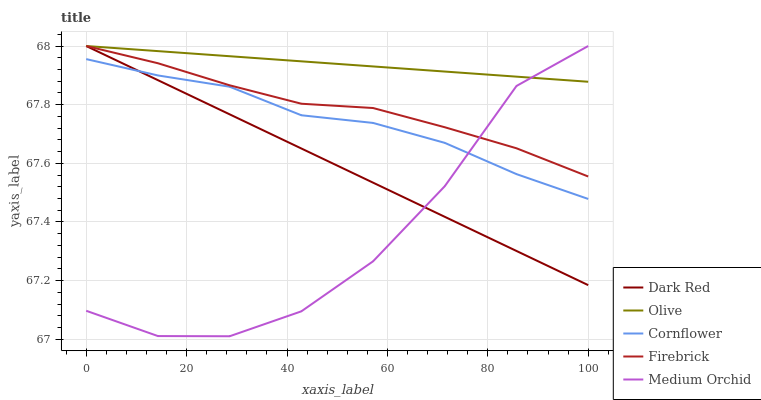Does Medium Orchid have the minimum area under the curve?
Answer yes or no. Yes. Does Olive have the maximum area under the curve?
Answer yes or no. Yes. Does Dark Red have the minimum area under the curve?
Answer yes or no. No. Does Dark Red have the maximum area under the curve?
Answer yes or no. No. Is Olive the smoothest?
Answer yes or no. Yes. Is Medium Orchid the roughest?
Answer yes or no. Yes. Is Dark Red the smoothest?
Answer yes or no. No. Is Dark Red the roughest?
Answer yes or no. No. Does Medium Orchid have the lowest value?
Answer yes or no. Yes. Does Dark Red have the lowest value?
Answer yes or no. No. Does Medium Orchid have the highest value?
Answer yes or no. Yes. Does Cornflower have the highest value?
Answer yes or no. No. Is Cornflower less than Olive?
Answer yes or no. Yes. Is Firebrick greater than Cornflower?
Answer yes or no. Yes. Does Firebrick intersect Medium Orchid?
Answer yes or no. Yes. Is Firebrick less than Medium Orchid?
Answer yes or no. No. Is Firebrick greater than Medium Orchid?
Answer yes or no. No. Does Cornflower intersect Olive?
Answer yes or no. No. 